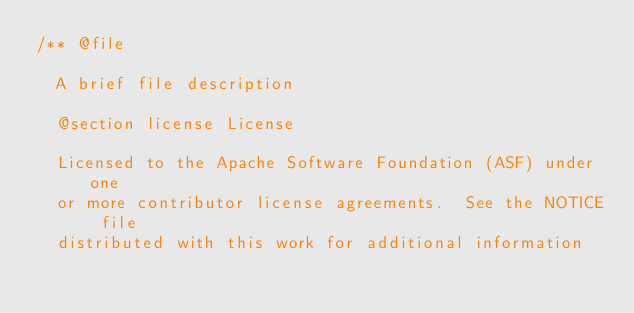Convert code to text. <code><loc_0><loc_0><loc_500><loc_500><_C++_>/** @file

  A brief file description

  @section license License

  Licensed to the Apache Software Foundation (ASF) under one
  or more contributor license agreements.  See the NOTICE file
  distributed with this work for additional information</code> 